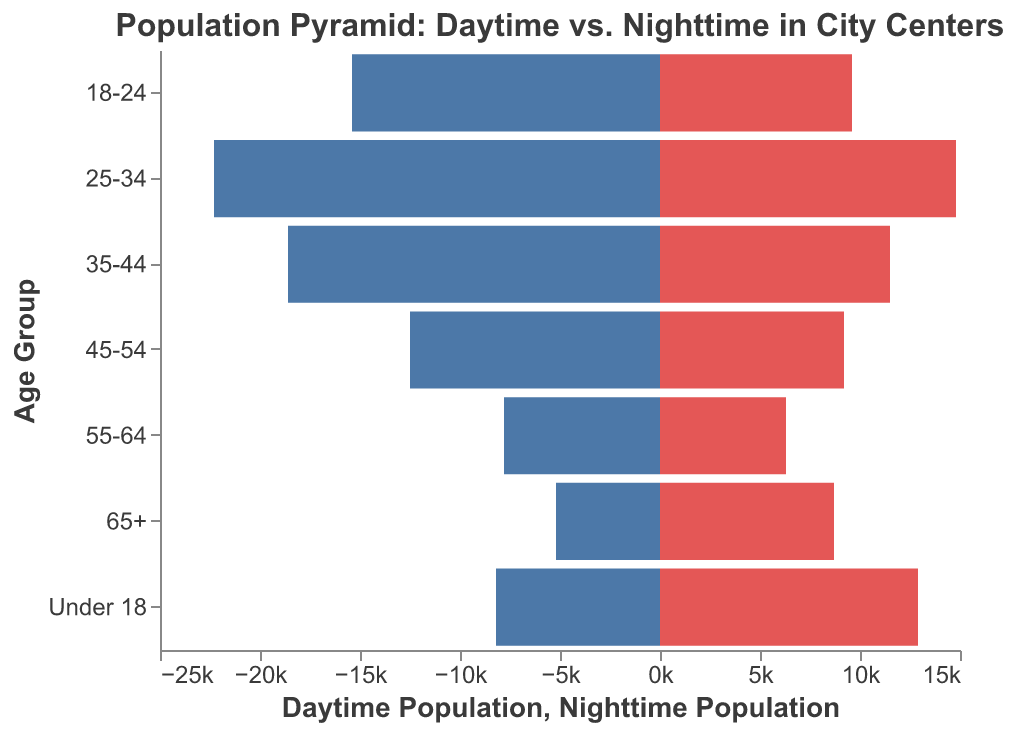What is the title of the figure? The title is located at the top of the figure and provides a summary of the content.
Answer: Population Pyramid: Daytime vs. Nighttime in City Centers Which age group has the highest daytime population? By examining the bars on the left side of the pyramid, the age group with the longest bar represents the highest daytime population.
Answer: 25-34 Which age group has the highest nighttime population? By examining the bars on the right side of the pyramid, the age group with the longest bar represents the highest nighttime population.
Answer: 25-34 How does the daytime population for the 18-24 age group compare to its nighttime population? Look at the lengths of the bars corresponding to the 18-24 age group. The daytime population bar is longer than the nighttime population bar.
Answer: The daytime population is higher What is the total nighttime population from the dataset? Sum the nighttime population values for all age groups: 8700 + 6300 + 9200 + 11500 + 14800 + 9600 + 12900. The sum represents the total nighttime population.
Answer: 72,000 Which age group sees the biggest difference between its daytime and nighttime population? Calculate the difference for each age group and identify the maximum: 
65+: 8700 - 5200 = 3500
55-64: 7800 - 6300 = 1500
45-54: 12500 - 9200 = 3300
35-44: 18600 - 11500 = 7100
25-34: 22300 - 14800 = 7500
18-24: 15400 - 9600 = 5800
Under 18: 12900 - 8200 = 4700
The age group 25-34 shows the largest difference.
Answer: 25-34 For the age group 55-64, is the daytime population greater than the nighttime population? Compare the two values specifically for the 55-64 age group; the daytime population is 7800, while the nighttime population is 6300.
Answer: Yes Which age group has a larger share of the nighttime population compared to its daytime population? Identify the group where the nighttime population bar is longer than the daytime population bar.
Answer: 65+, Under 18 What is the average daytime population across all age groups? Sum the daytime populations and divide by the number of age groups: (5200 + 7800 + 12500 + 18600 + 22300 + 15400 + 8200) / 7.
Answer: 12,686 